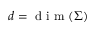<formula> <loc_0><loc_0><loc_500><loc_500>d = d i m ( \Sigma )</formula> 